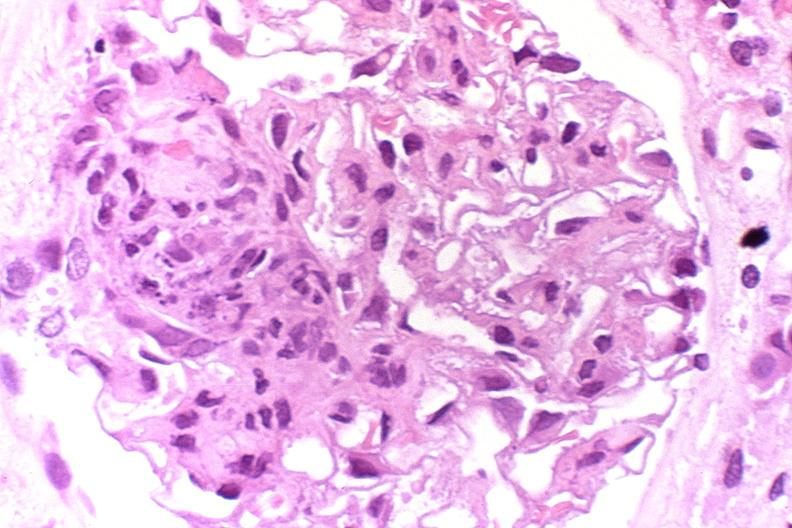does this image show glomerulonephritis, sle iii?
Answer the question using a single word or phrase. Yes 